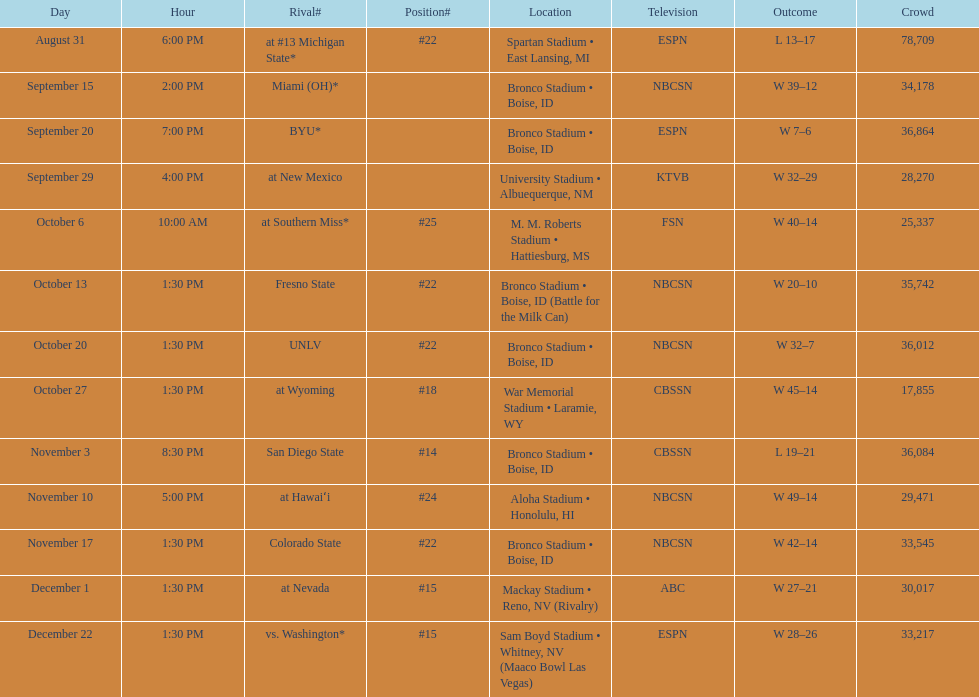What is the score difference for the game against michigan state? 4. 